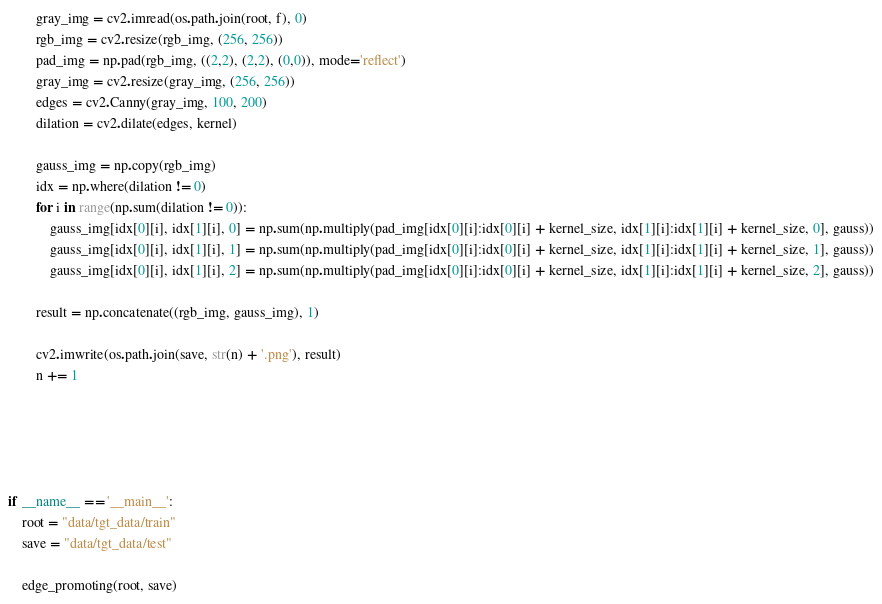Convert code to text. <code><loc_0><loc_0><loc_500><loc_500><_Python_>        gray_img = cv2.imread(os.path.join(root, f), 0)
        rgb_img = cv2.resize(rgb_img, (256, 256))
        pad_img = np.pad(rgb_img, ((2,2), (2,2), (0,0)), mode='reflect')
        gray_img = cv2.resize(gray_img, (256, 256))
        edges = cv2.Canny(gray_img, 100, 200)
        dilation = cv2.dilate(edges, kernel)

        gauss_img = np.copy(rgb_img)
        idx = np.where(dilation != 0)
        for i in range(np.sum(dilation != 0)):
            gauss_img[idx[0][i], idx[1][i], 0] = np.sum(np.multiply(pad_img[idx[0][i]:idx[0][i] + kernel_size, idx[1][i]:idx[1][i] + kernel_size, 0], gauss))
            gauss_img[idx[0][i], idx[1][i], 1] = np.sum(np.multiply(pad_img[idx[0][i]:idx[0][i] + kernel_size, idx[1][i]:idx[1][i] + kernel_size, 1], gauss))
            gauss_img[idx[0][i], idx[1][i], 2] = np.sum(np.multiply(pad_img[idx[0][i]:idx[0][i] + kernel_size, idx[1][i]:idx[1][i] + kernel_size, 2], gauss))

        result = np.concatenate((rgb_img, gauss_img), 1)

        cv2.imwrite(os.path.join(save, str(n) + '.png'), result)
        n += 1





if __name__ == '__main__':
    root = "data/tgt_data/train"
    save = "data/tgt_data/test"

    edge_promoting(root, save)</code> 